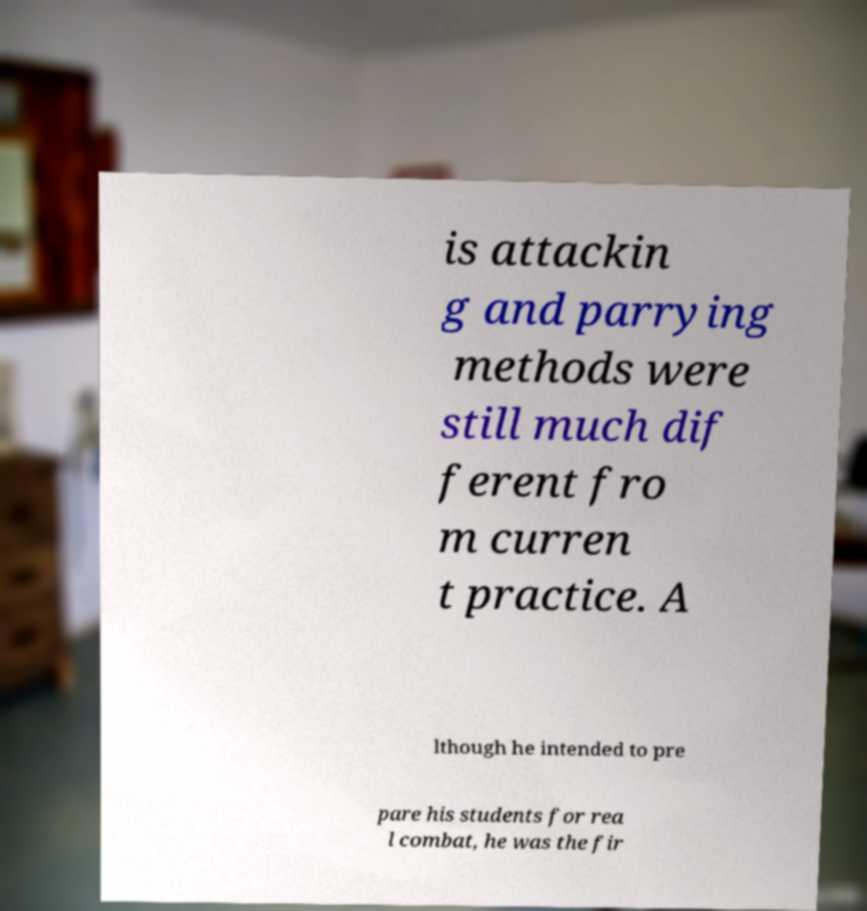Please identify and transcribe the text found in this image. is attackin g and parrying methods were still much dif ferent fro m curren t practice. A lthough he intended to pre pare his students for rea l combat, he was the fir 